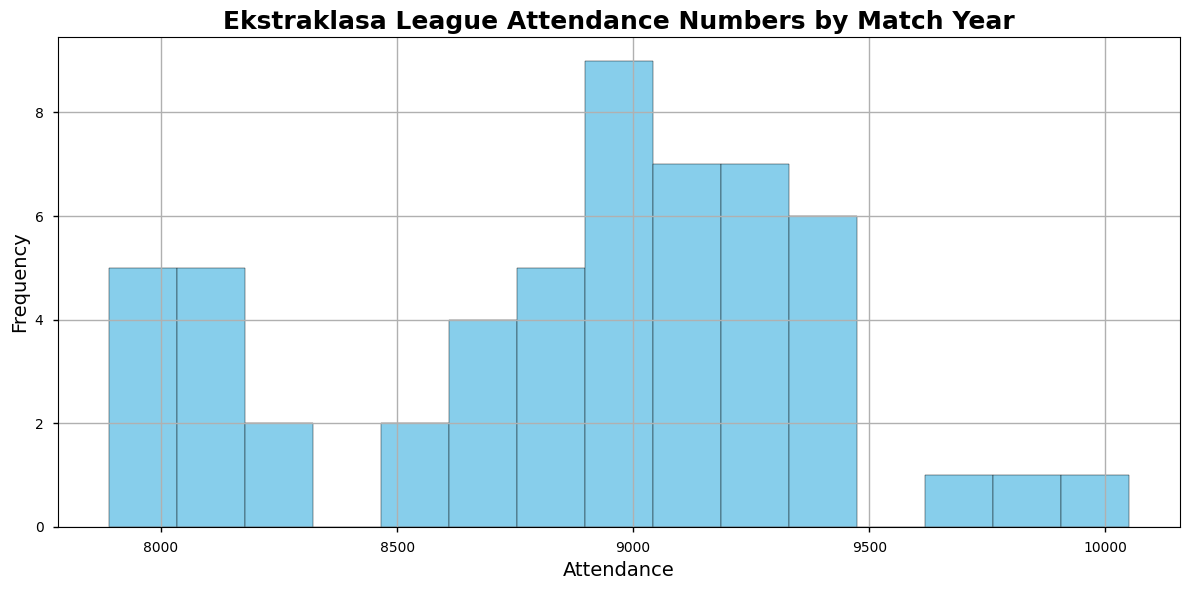What's the most common attendance range in the Ekstraklasa League based on the histogram? The histogram will show the intervals on the x-axis representing attendance ranges. Identify the bin (interval) with the highest bar (frequency) to determine the most common range.
Answer: Look for the highest bar on the histogram to find the most common attendance range Which year seemed to have the highest attendance in matches based on the data provided? To determine this, identify the highest attendance figures across the data set for each year and look for the peak value on the histogram. The highest peaks reflect the most attended matches, which can be cross-referenced with the year.
Answer: The year with the highest peak attendance value What is the approximate range of the lowest attendance figures represented in the histogram? Look for the bins on the left end of the histogram which will show the smallest attendance values. These depict the lowest attendance ranges. Identify the range by noting the values at the edges of these bins.
Answer: The lowest attendance range approximated by the leftmost bins in the histogram How does the frequency of the 8000-9000 attendance range compare to the 9000-10000 range in the histogram? Look at the heights of the bars within the 8000-9000 range and compare them to the heights of bars in the 9000-10000 range. The comparison is done visually by examining which bar heights are taller.
Answer: Comparison of bar heights between the 8000-9000 and 9000-10000 attendance ranges Are there more matches with attendance above 9000 or below 9000? Split the histogram at the 9000 attendance mark. Count the number of bars above and below this value and compare the totals.
Answer: Compare the number of bars above and below the 9000 attendance mark Is there a clear peak in the attendance numbers, or is the distribution more uniform? Observing the histogram, look for any single, prominent peak versus a relatively flat distribution with several smaller peaks.
Answer: Single peak or uniform distribution question based on visual peaks in the histogram What's the average attendance based on the histogram data? While the histogram helps visually, the average attendance is computed by summing individual attendance figures and dividing by the total number of matches. To answer, estimate the center of mass of the frequency distribution.
Answer: The estimation of the average attendance by center of mass on the histogram In which attendance range is it less common to have matches? Identify the bins with the shortest bars in the histogram, as these represent attendance ranges with fewer matches.
Answer: The attendance ranges with the shortest bars indicate rare attendance values How does the attendance distribution change across decades? Though the histogram shows overall distribution, the data provided can be sliced by years to observe changes over time. Look for shifts or trends over the years represented.
Answer: Inspecting changes visually over decade intervals based on bin distribution How uniform are the attendance numbers? Look at the relative diversity in the histogram bin heights. A uniform distribution would have bars of nearly equal height, whereas non-uniform would show significant variance in bar heights.
Answer: Observing uniformity through similarity in histogram bar heights Is there any exceptional year in terms of significantly different attendance patterns? Spot significant deviations by checking for outlier years with unusually high or low attendance compared to others on the histogram.
Answer: Visual inspection of years with outlier highs or lows on the histogram 